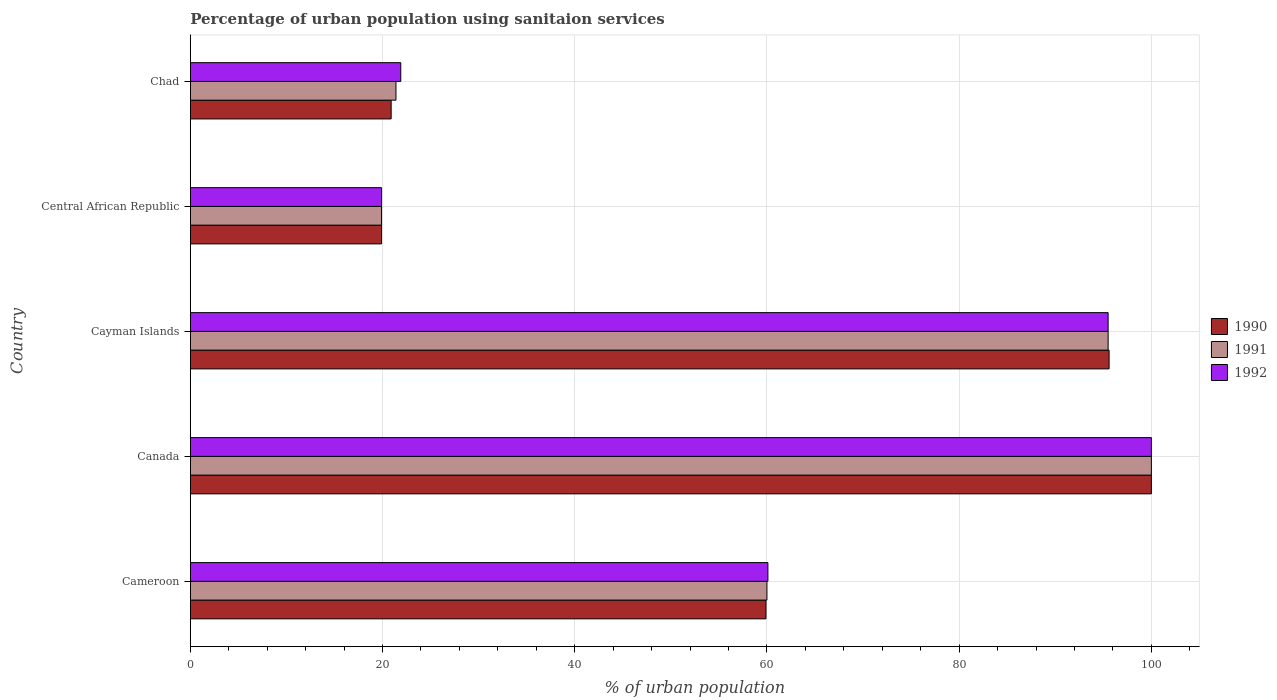How many groups of bars are there?
Your response must be concise. 5. How many bars are there on the 4th tick from the bottom?
Ensure brevity in your answer.  3. What is the label of the 4th group of bars from the top?
Provide a short and direct response. Canada. What is the percentage of urban population using sanitaion services in 1991 in Cameroon?
Ensure brevity in your answer.  60. Across all countries, what is the minimum percentage of urban population using sanitaion services in 1992?
Ensure brevity in your answer.  19.9. In which country was the percentage of urban population using sanitaion services in 1992 minimum?
Your response must be concise. Central African Republic. What is the total percentage of urban population using sanitaion services in 1991 in the graph?
Keep it short and to the point. 296.8. What is the difference between the percentage of urban population using sanitaion services in 1992 in Cameroon and that in Central African Republic?
Your answer should be compact. 40.2. What is the difference between the percentage of urban population using sanitaion services in 1992 in Canada and the percentage of urban population using sanitaion services in 1990 in Cayman Islands?
Give a very brief answer. 4.4. What is the average percentage of urban population using sanitaion services in 1991 per country?
Your answer should be very brief. 59.36. What is the difference between the percentage of urban population using sanitaion services in 1992 and percentage of urban population using sanitaion services in 1991 in Canada?
Offer a terse response. 0. What is the ratio of the percentage of urban population using sanitaion services in 1991 in Central African Republic to that in Chad?
Give a very brief answer. 0.93. Is the percentage of urban population using sanitaion services in 1991 in Cameroon less than that in Chad?
Offer a terse response. No. Is the difference between the percentage of urban population using sanitaion services in 1992 in Canada and Central African Republic greater than the difference between the percentage of urban population using sanitaion services in 1991 in Canada and Central African Republic?
Offer a terse response. No. What is the difference between the highest and the lowest percentage of urban population using sanitaion services in 1991?
Make the answer very short. 80.1. Is the sum of the percentage of urban population using sanitaion services in 1992 in Cayman Islands and Central African Republic greater than the maximum percentage of urban population using sanitaion services in 1990 across all countries?
Ensure brevity in your answer.  Yes. What does the 1st bar from the top in Chad represents?
Ensure brevity in your answer.  1992. How many bars are there?
Ensure brevity in your answer.  15. How many countries are there in the graph?
Make the answer very short. 5. Does the graph contain grids?
Offer a very short reply. Yes. Where does the legend appear in the graph?
Give a very brief answer. Center right. How are the legend labels stacked?
Provide a succinct answer. Vertical. What is the title of the graph?
Your response must be concise. Percentage of urban population using sanitaion services. Does "1986" appear as one of the legend labels in the graph?
Give a very brief answer. No. What is the label or title of the X-axis?
Offer a very short reply. % of urban population. What is the % of urban population of 1990 in Cameroon?
Provide a short and direct response. 59.9. What is the % of urban population of 1992 in Cameroon?
Offer a terse response. 60.1. What is the % of urban population of 1992 in Canada?
Your answer should be compact. 100. What is the % of urban population of 1990 in Cayman Islands?
Your answer should be very brief. 95.6. What is the % of urban population in 1991 in Cayman Islands?
Your answer should be compact. 95.5. What is the % of urban population of 1992 in Cayman Islands?
Give a very brief answer. 95.5. What is the % of urban population in 1990 in Central African Republic?
Offer a very short reply. 19.9. What is the % of urban population in 1991 in Central African Republic?
Offer a terse response. 19.9. What is the % of urban population of 1992 in Central African Republic?
Ensure brevity in your answer.  19.9. What is the % of urban population of 1990 in Chad?
Provide a short and direct response. 20.9. What is the % of urban population in 1991 in Chad?
Make the answer very short. 21.4. What is the % of urban population of 1992 in Chad?
Offer a terse response. 21.9. Across all countries, what is the maximum % of urban population in 1990?
Your answer should be very brief. 100. Across all countries, what is the maximum % of urban population in 1991?
Offer a terse response. 100. Across all countries, what is the minimum % of urban population of 1990?
Ensure brevity in your answer.  19.9. Across all countries, what is the minimum % of urban population in 1991?
Give a very brief answer. 19.9. Across all countries, what is the minimum % of urban population in 1992?
Offer a terse response. 19.9. What is the total % of urban population of 1990 in the graph?
Provide a succinct answer. 296.3. What is the total % of urban population of 1991 in the graph?
Provide a succinct answer. 296.8. What is the total % of urban population of 1992 in the graph?
Offer a terse response. 297.4. What is the difference between the % of urban population of 1990 in Cameroon and that in Canada?
Ensure brevity in your answer.  -40.1. What is the difference between the % of urban population in 1991 in Cameroon and that in Canada?
Your answer should be very brief. -40. What is the difference between the % of urban population of 1992 in Cameroon and that in Canada?
Your response must be concise. -39.9. What is the difference between the % of urban population in 1990 in Cameroon and that in Cayman Islands?
Your answer should be very brief. -35.7. What is the difference between the % of urban population in 1991 in Cameroon and that in Cayman Islands?
Keep it short and to the point. -35.5. What is the difference between the % of urban population of 1992 in Cameroon and that in Cayman Islands?
Your response must be concise. -35.4. What is the difference between the % of urban population in 1990 in Cameroon and that in Central African Republic?
Offer a terse response. 40. What is the difference between the % of urban population of 1991 in Cameroon and that in Central African Republic?
Keep it short and to the point. 40.1. What is the difference between the % of urban population of 1992 in Cameroon and that in Central African Republic?
Provide a succinct answer. 40.2. What is the difference between the % of urban population in 1991 in Cameroon and that in Chad?
Your answer should be very brief. 38.6. What is the difference between the % of urban population of 1992 in Cameroon and that in Chad?
Offer a terse response. 38.2. What is the difference between the % of urban population of 1991 in Canada and that in Cayman Islands?
Provide a succinct answer. 4.5. What is the difference between the % of urban population of 1992 in Canada and that in Cayman Islands?
Offer a very short reply. 4.5. What is the difference between the % of urban population in 1990 in Canada and that in Central African Republic?
Your answer should be very brief. 80.1. What is the difference between the % of urban population of 1991 in Canada and that in Central African Republic?
Keep it short and to the point. 80.1. What is the difference between the % of urban population of 1992 in Canada and that in Central African Republic?
Give a very brief answer. 80.1. What is the difference between the % of urban population of 1990 in Canada and that in Chad?
Your answer should be compact. 79.1. What is the difference between the % of urban population in 1991 in Canada and that in Chad?
Ensure brevity in your answer.  78.6. What is the difference between the % of urban population of 1992 in Canada and that in Chad?
Provide a succinct answer. 78.1. What is the difference between the % of urban population of 1990 in Cayman Islands and that in Central African Republic?
Your answer should be compact. 75.7. What is the difference between the % of urban population in 1991 in Cayman Islands and that in Central African Republic?
Provide a short and direct response. 75.6. What is the difference between the % of urban population in 1992 in Cayman Islands and that in Central African Republic?
Make the answer very short. 75.6. What is the difference between the % of urban population in 1990 in Cayman Islands and that in Chad?
Provide a succinct answer. 74.7. What is the difference between the % of urban population of 1991 in Cayman Islands and that in Chad?
Keep it short and to the point. 74.1. What is the difference between the % of urban population of 1992 in Cayman Islands and that in Chad?
Make the answer very short. 73.6. What is the difference between the % of urban population of 1990 in Central African Republic and that in Chad?
Offer a very short reply. -1. What is the difference between the % of urban population in 1990 in Cameroon and the % of urban population in 1991 in Canada?
Ensure brevity in your answer.  -40.1. What is the difference between the % of urban population in 1990 in Cameroon and the % of urban population in 1992 in Canada?
Offer a very short reply. -40.1. What is the difference between the % of urban population of 1991 in Cameroon and the % of urban population of 1992 in Canada?
Ensure brevity in your answer.  -40. What is the difference between the % of urban population of 1990 in Cameroon and the % of urban population of 1991 in Cayman Islands?
Make the answer very short. -35.6. What is the difference between the % of urban population of 1990 in Cameroon and the % of urban population of 1992 in Cayman Islands?
Give a very brief answer. -35.6. What is the difference between the % of urban population in 1991 in Cameroon and the % of urban population in 1992 in Cayman Islands?
Offer a terse response. -35.5. What is the difference between the % of urban population in 1990 in Cameroon and the % of urban population in 1991 in Central African Republic?
Give a very brief answer. 40. What is the difference between the % of urban population of 1991 in Cameroon and the % of urban population of 1992 in Central African Republic?
Provide a short and direct response. 40.1. What is the difference between the % of urban population in 1990 in Cameroon and the % of urban population in 1991 in Chad?
Offer a terse response. 38.5. What is the difference between the % of urban population of 1991 in Cameroon and the % of urban population of 1992 in Chad?
Give a very brief answer. 38.1. What is the difference between the % of urban population of 1990 in Canada and the % of urban population of 1992 in Cayman Islands?
Ensure brevity in your answer.  4.5. What is the difference between the % of urban population in 1990 in Canada and the % of urban population in 1991 in Central African Republic?
Make the answer very short. 80.1. What is the difference between the % of urban population of 1990 in Canada and the % of urban population of 1992 in Central African Republic?
Provide a short and direct response. 80.1. What is the difference between the % of urban population of 1991 in Canada and the % of urban population of 1992 in Central African Republic?
Keep it short and to the point. 80.1. What is the difference between the % of urban population of 1990 in Canada and the % of urban population of 1991 in Chad?
Your answer should be compact. 78.6. What is the difference between the % of urban population of 1990 in Canada and the % of urban population of 1992 in Chad?
Your answer should be compact. 78.1. What is the difference between the % of urban population in 1991 in Canada and the % of urban population in 1992 in Chad?
Provide a short and direct response. 78.1. What is the difference between the % of urban population in 1990 in Cayman Islands and the % of urban population in 1991 in Central African Republic?
Make the answer very short. 75.7. What is the difference between the % of urban population of 1990 in Cayman Islands and the % of urban population of 1992 in Central African Republic?
Provide a succinct answer. 75.7. What is the difference between the % of urban population of 1991 in Cayman Islands and the % of urban population of 1992 in Central African Republic?
Provide a short and direct response. 75.6. What is the difference between the % of urban population in 1990 in Cayman Islands and the % of urban population in 1991 in Chad?
Offer a terse response. 74.2. What is the difference between the % of urban population of 1990 in Cayman Islands and the % of urban population of 1992 in Chad?
Provide a short and direct response. 73.7. What is the difference between the % of urban population in 1991 in Cayman Islands and the % of urban population in 1992 in Chad?
Your answer should be compact. 73.6. What is the difference between the % of urban population of 1990 in Central African Republic and the % of urban population of 1991 in Chad?
Provide a short and direct response. -1.5. What is the difference between the % of urban population in 1990 in Central African Republic and the % of urban population in 1992 in Chad?
Give a very brief answer. -2. What is the average % of urban population in 1990 per country?
Your answer should be compact. 59.26. What is the average % of urban population in 1991 per country?
Ensure brevity in your answer.  59.36. What is the average % of urban population of 1992 per country?
Offer a terse response. 59.48. What is the difference between the % of urban population in 1990 and % of urban population in 1991 in Cameroon?
Provide a succinct answer. -0.1. What is the difference between the % of urban population of 1990 and % of urban population of 1992 in Cameroon?
Provide a short and direct response. -0.2. What is the difference between the % of urban population of 1990 and % of urban population of 1991 in Canada?
Your response must be concise. 0. What is the difference between the % of urban population in 1990 and % of urban population in 1992 in Canada?
Your answer should be compact. 0. What is the difference between the % of urban population in 1991 and % of urban population in 1992 in Canada?
Ensure brevity in your answer.  0. What is the difference between the % of urban population of 1990 and % of urban population of 1992 in Cayman Islands?
Offer a very short reply. 0.1. What is the difference between the % of urban population in 1990 and % of urban population in 1991 in Central African Republic?
Give a very brief answer. 0. What is the ratio of the % of urban population in 1990 in Cameroon to that in Canada?
Provide a succinct answer. 0.6. What is the ratio of the % of urban population in 1992 in Cameroon to that in Canada?
Your response must be concise. 0.6. What is the ratio of the % of urban population in 1990 in Cameroon to that in Cayman Islands?
Your answer should be compact. 0.63. What is the ratio of the % of urban population in 1991 in Cameroon to that in Cayman Islands?
Your answer should be very brief. 0.63. What is the ratio of the % of urban population of 1992 in Cameroon to that in Cayman Islands?
Provide a succinct answer. 0.63. What is the ratio of the % of urban population in 1990 in Cameroon to that in Central African Republic?
Provide a succinct answer. 3.01. What is the ratio of the % of urban population of 1991 in Cameroon to that in Central African Republic?
Offer a very short reply. 3.02. What is the ratio of the % of urban population of 1992 in Cameroon to that in Central African Republic?
Provide a short and direct response. 3.02. What is the ratio of the % of urban population in 1990 in Cameroon to that in Chad?
Provide a short and direct response. 2.87. What is the ratio of the % of urban population of 1991 in Cameroon to that in Chad?
Give a very brief answer. 2.8. What is the ratio of the % of urban population in 1992 in Cameroon to that in Chad?
Your answer should be compact. 2.74. What is the ratio of the % of urban population in 1990 in Canada to that in Cayman Islands?
Give a very brief answer. 1.05. What is the ratio of the % of urban population in 1991 in Canada to that in Cayman Islands?
Offer a terse response. 1.05. What is the ratio of the % of urban population in 1992 in Canada to that in Cayman Islands?
Your answer should be compact. 1.05. What is the ratio of the % of urban population of 1990 in Canada to that in Central African Republic?
Your answer should be very brief. 5.03. What is the ratio of the % of urban population in 1991 in Canada to that in Central African Republic?
Ensure brevity in your answer.  5.03. What is the ratio of the % of urban population of 1992 in Canada to that in Central African Republic?
Provide a succinct answer. 5.03. What is the ratio of the % of urban population of 1990 in Canada to that in Chad?
Ensure brevity in your answer.  4.78. What is the ratio of the % of urban population in 1991 in Canada to that in Chad?
Offer a terse response. 4.67. What is the ratio of the % of urban population of 1992 in Canada to that in Chad?
Offer a terse response. 4.57. What is the ratio of the % of urban population of 1990 in Cayman Islands to that in Central African Republic?
Provide a short and direct response. 4.8. What is the ratio of the % of urban population in 1991 in Cayman Islands to that in Central African Republic?
Offer a very short reply. 4.8. What is the ratio of the % of urban population of 1992 in Cayman Islands to that in Central African Republic?
Keep it short and to the point. 4.8. What is the ratio of the % of urban population in 1990 in Cayman Islands to that in Chad?
Offer a very short reply. 4.57. What is the ratio of the % of urban population of 1991 in Cayman Islands to that in Chad?
Keep it short and to the point. 4.46. What is the ratio of the % of urban population of 1992 in Cayman Islands to that in Chad?
Provide a short and direct response. 4.36. What is the ratio of the % of urban population in 1990 in Central African Republic to that in Chad?
Give a very brief answer. 0.95. What is the ratio of the % of urban population of 1991 in Central African Republic to that in Chad?
Ensure brevity in your answer.  0.93. What is the ratio of the % of urban population in 1992 in Central African Republic to that in Chad?
Your response must be concise. 0.91. What is the difference between the highest and the second highest % of urban population of 1992?
Make the answer very short. 4.5. What is the difference between the highest and the lowest % of urban population in 1990?
Your answer should be very brief. 80.1. What is the difference between the highest and the lowest % of urban population in 1991?
Ensure brevity in your answer.  80.1. What is the difference between the highest and the lowest % of urban population of 1992?
Your answer should be compact. 80.1. 